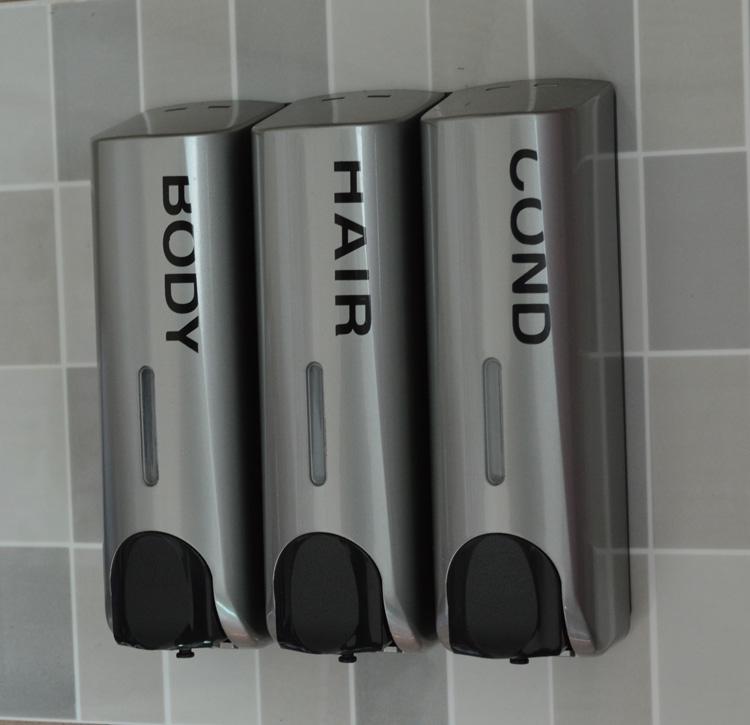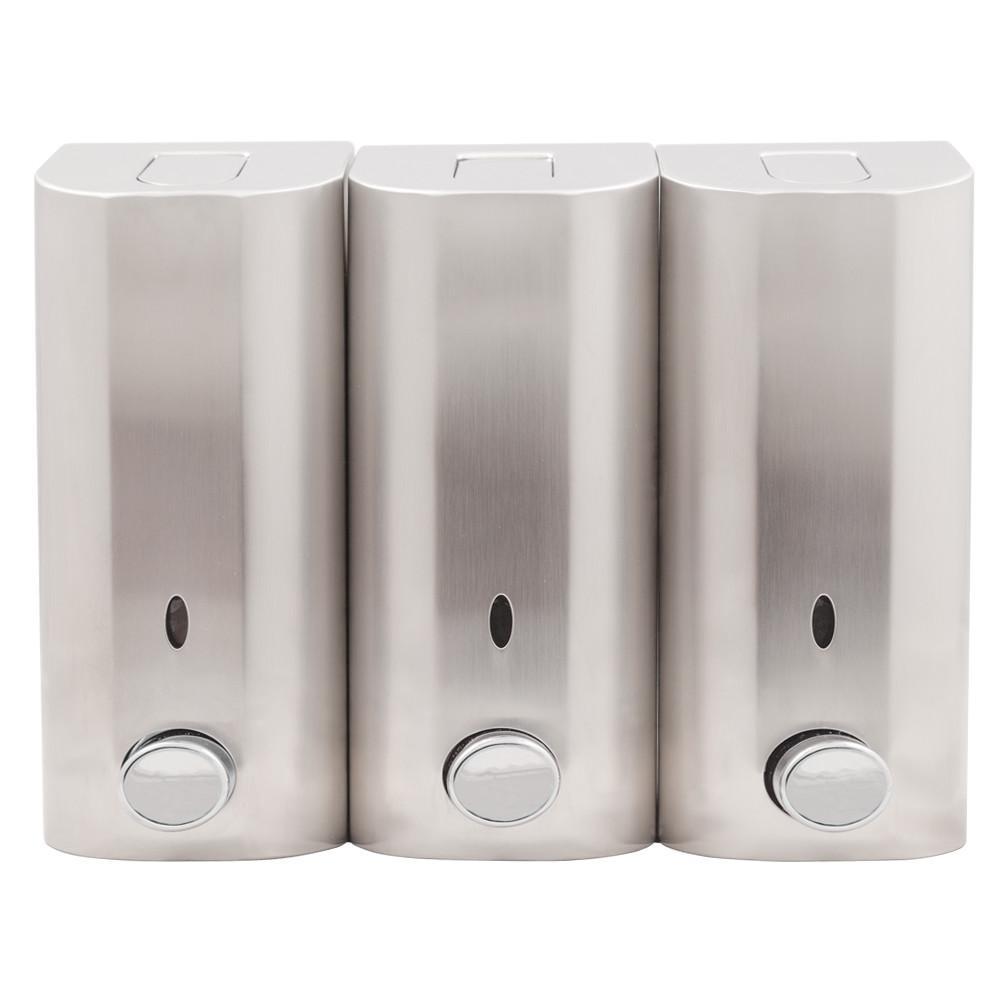The first image is the image on the left, the second image is the image on the right. For the images shown, is this caption "Each image shows a bank of three lotion dispensers, but only one set has the contents written on each dispenser." true? Answer yes or no. Yes. The first image is the image on the left, the second image is the image on the right. Considering the images on both sides, is "The left and right image contains the same number of wall soap dispensers." valid? Answer yes or no. Yes. 